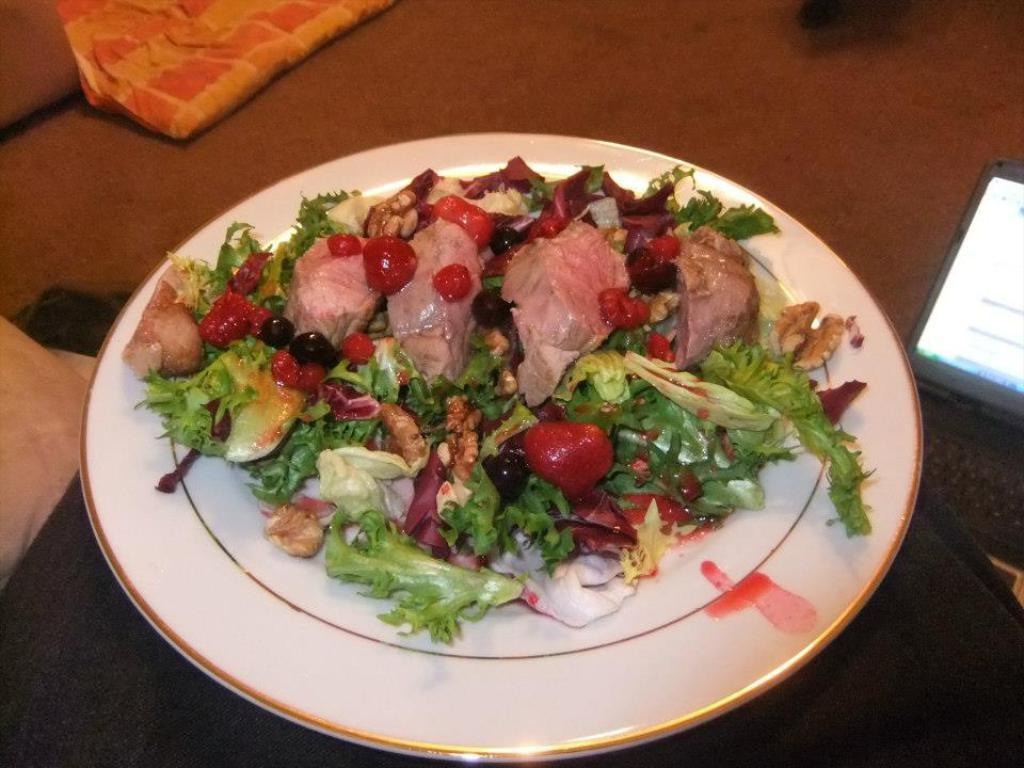What type of food is on the plate in the image? There is a plate of salad with meat in the image. What additional ingredients are in the salad? There are berries in the plate. What electronic device is placed on the floor in the image? There is a laptop placed on the floor. What type of soft furnishings can be seen in the image? There are pillows and blankets in the image. What type of alley can be seen in the image? There is no alley present in the image. Is there a maid preparing the salad in the image? There is no maid present in the image; the salad is already prepared on the plate. 